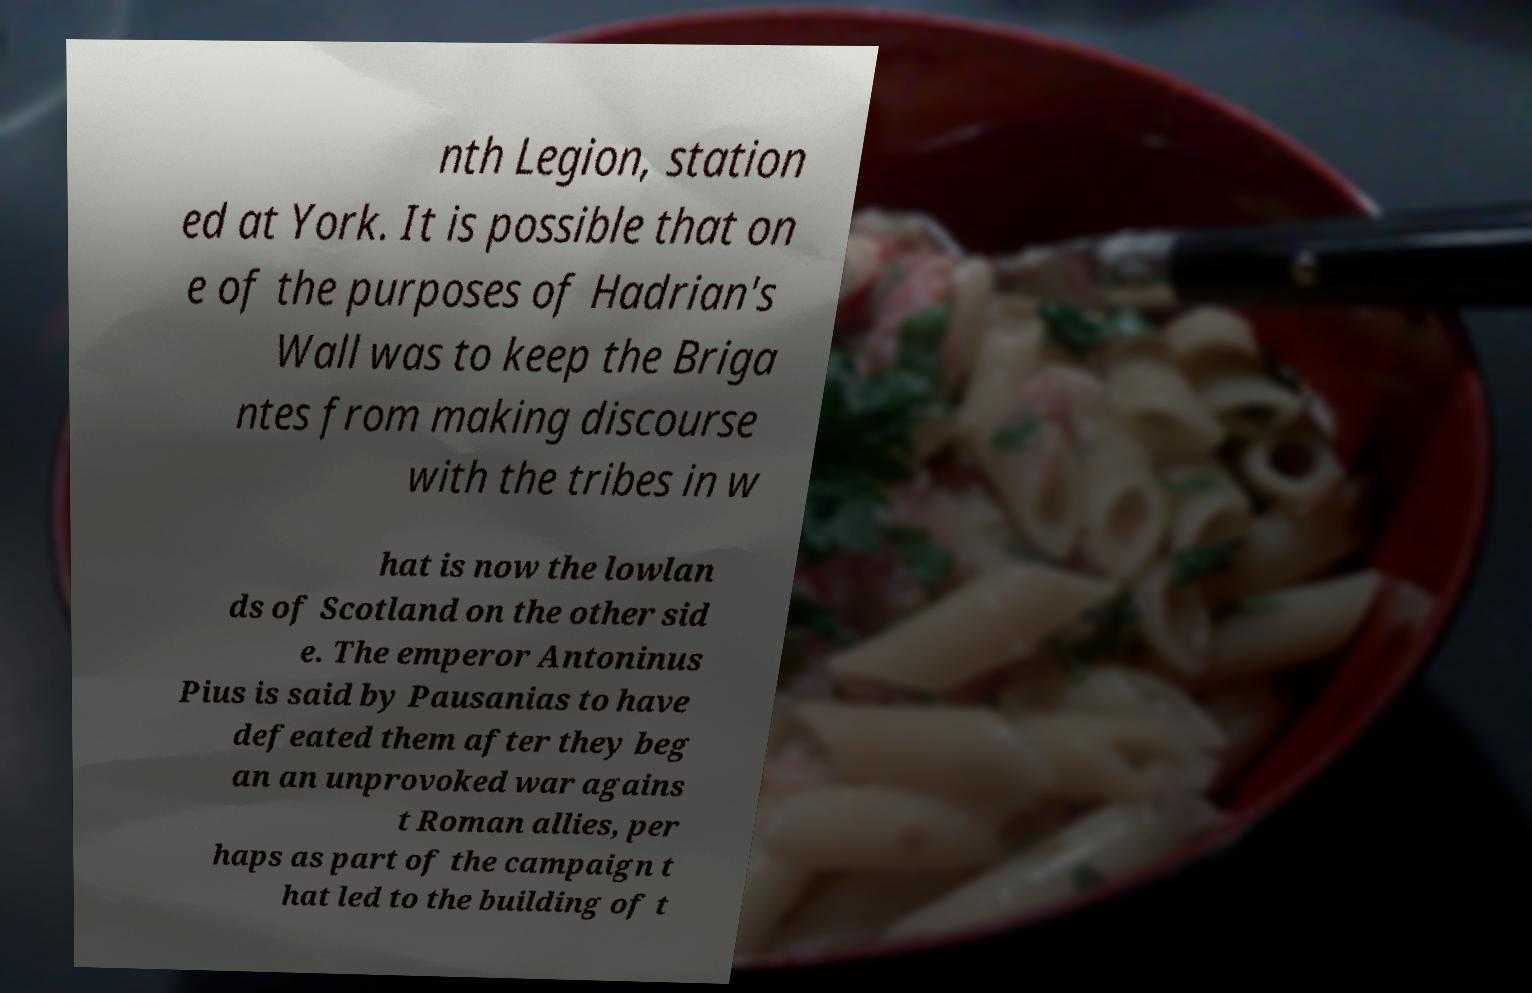Please read and relay the text visible in this image. What does it say? nth Legion, station ed at York. It is possible that on e of the purposes of Hadrian's Wall was to keep the Briga ntes from making discourse with the tribes in w hat is now the lowlan ds of Scotland on the other sid e. The emperor Antoninus Pius is said by Pausanias to have defeated them after they beg an an unprovoked war agains t Roman allies, per haps as part of the campaign t hat led to the building of t 